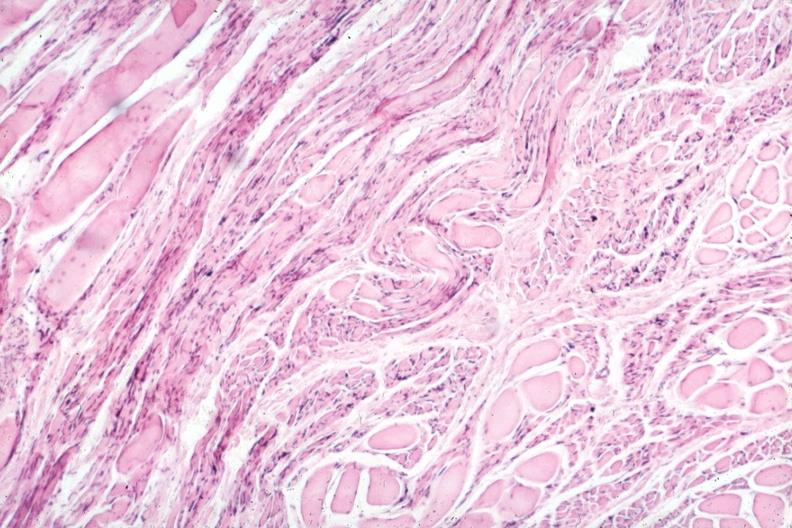does this image show marked neurological atrophy?
Answer the question using a single word or phrase. Yes 